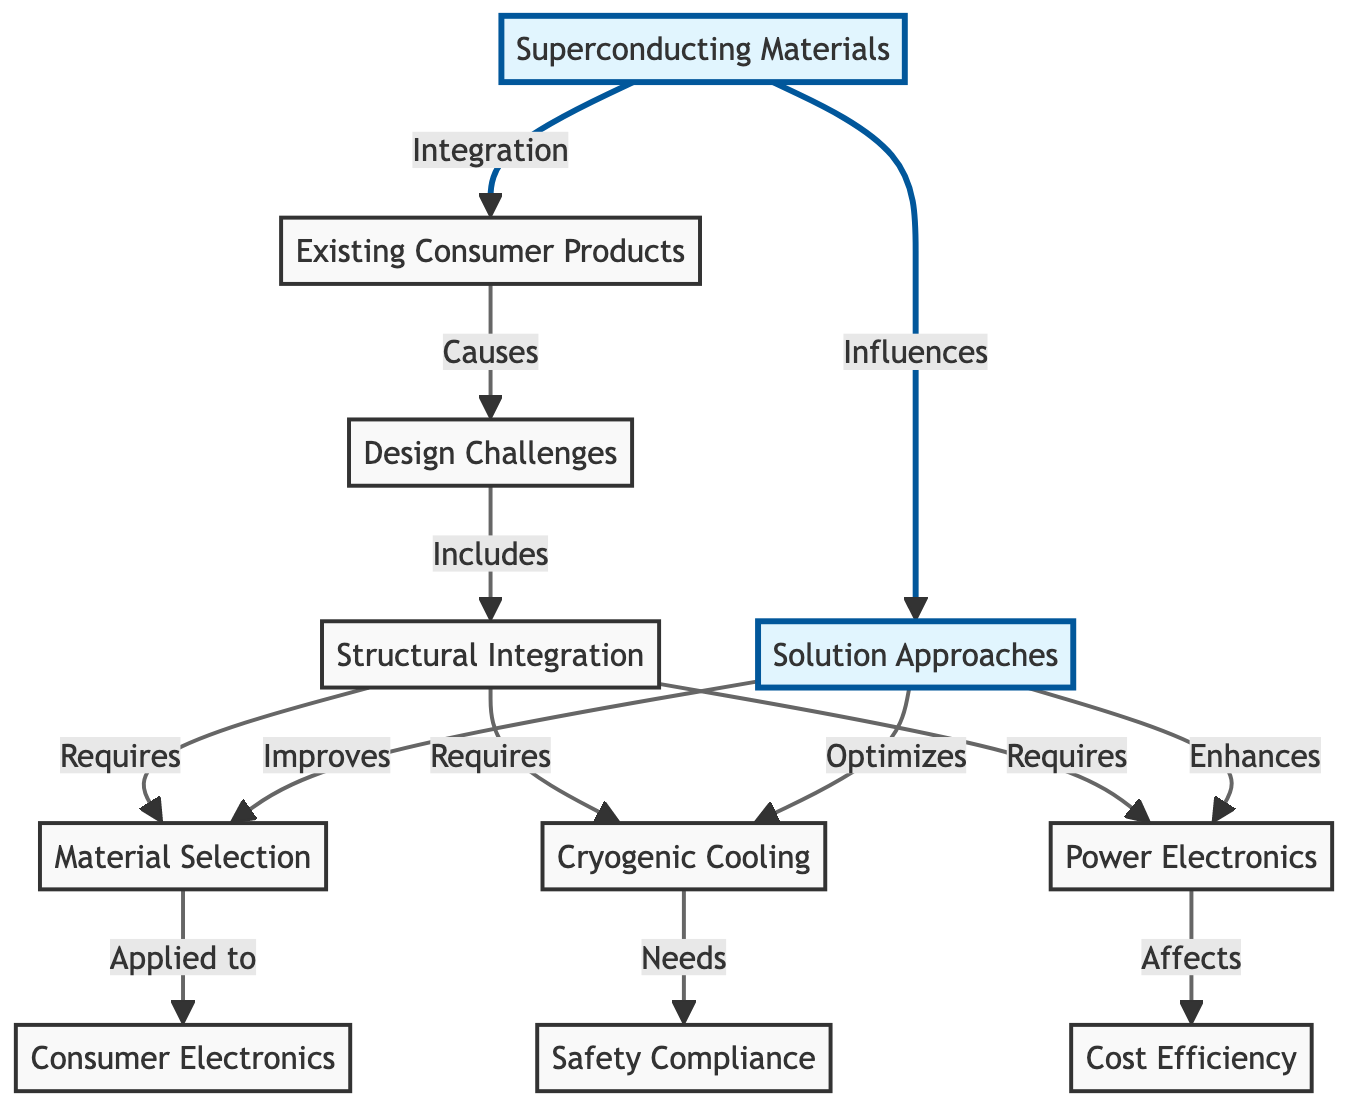What is the main element highlighted in the diagram? The highlighted element is "Superconducting Materials," which is clearly indicated in the diagram. It is marked with a different color to draw attention.
Answer: Superconducting Materials How many main elements are shown in the diagram? The diagram contains a total of eight main elements (nodes), including Superconducting Materials and other related concepts.
Answer: Eight What is the relationship between Existing Consumer Products and Design Challenges? The diagram indicates a causal relationship where Existing Consumer Products lead to Design Challenges. Thus, Design Challenges are caused by the integration of Superconducting Materials into Existing Consumer Products.
Answer: Causes Which node requires Power Electronics? The node "Structural Integration" explicitly lists "Power Electronics" as a requirement for achieving integration.
Answer: Structural Integration What influence do Superconducting Materials have on Solutions Approaches? The diagram shows that Superconducting Materials influence Solution Approaches, indicating a direct relationship between these two concepts.
Answer: Influences What requires both Material Selection and Cryogenic Cooling in the diagram? The node "Structural Integration" directly indicates that it requires both Material Selection and Cryogenic Cooling for successful integration.
Answer: Structural Integration How does the element Cryogenic Cooling relate to Safety Compliance? According to the diagram, Cryogenic Cooling needs Safety Compliance, meaning that considerations regarding safety are essential for implementing cooling systems.
Answer: Needs What element directly impacts Cost Efficiency? The diagram indicates that "Power Electronics" affects Cost Efficiency, establishing a clear connection between these two aspects.
Answer: Power Electronics What are two outcomes of Solution Approaches depicted in the diagram? The diagram illustrates that Solution Approaches improve Material Selection and optimize Cryogenic Cooling, highlighting their benefits.
Answer: Improve Material Selection and Optimize Cryogenic Cooling Which node is indicated as a prerequisite for Structural Integration? The diagram states that both Material Selection and Cryogenic Cooling are required for Structural Integration, identifying these as essential prerequisites.
Answer: Material Selection and Cryogenic Cooling 